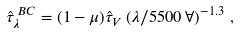<formula> <loc_0><loc_0><loc_500><loc_500>\hat { \tau } _ { \lambda } ^ { \, B C } = ( 1 - \mu ) \hat { \tau } _ { V } \left ( \lambda / { 5 5 0 0 \, \AA } \right ) ^ { - 1 . 3 } \, ,</formula> 